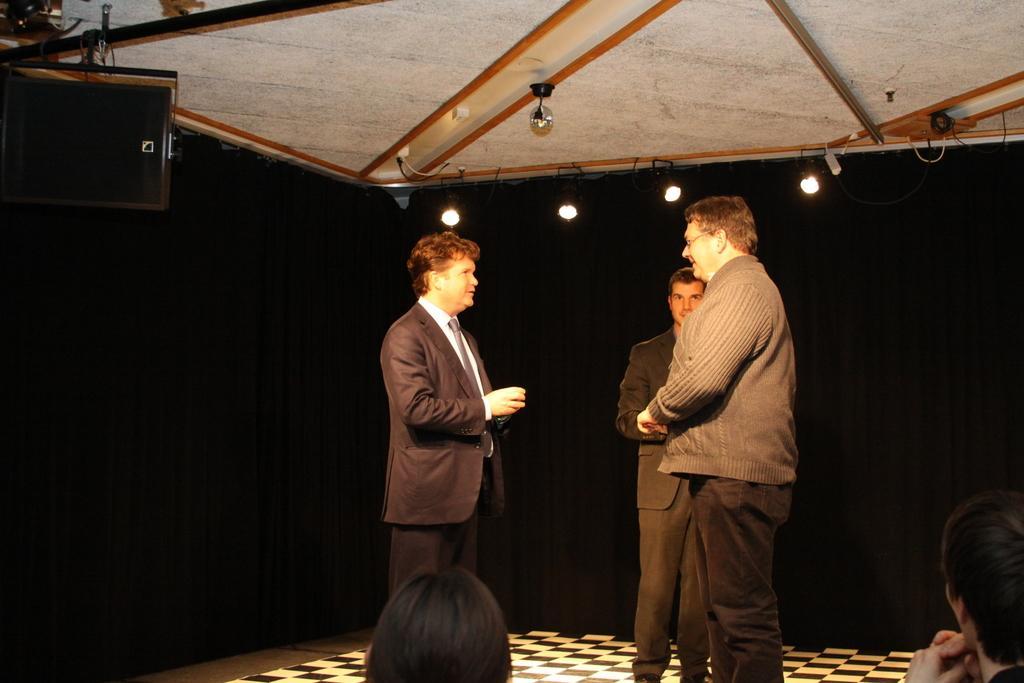Can you describe this image briefly? In the center of the image there are three persons standing. In the background of the image there is black color cloth. At the top of the image there is ceiling. There are lights. At the bottom of the image there are people. 